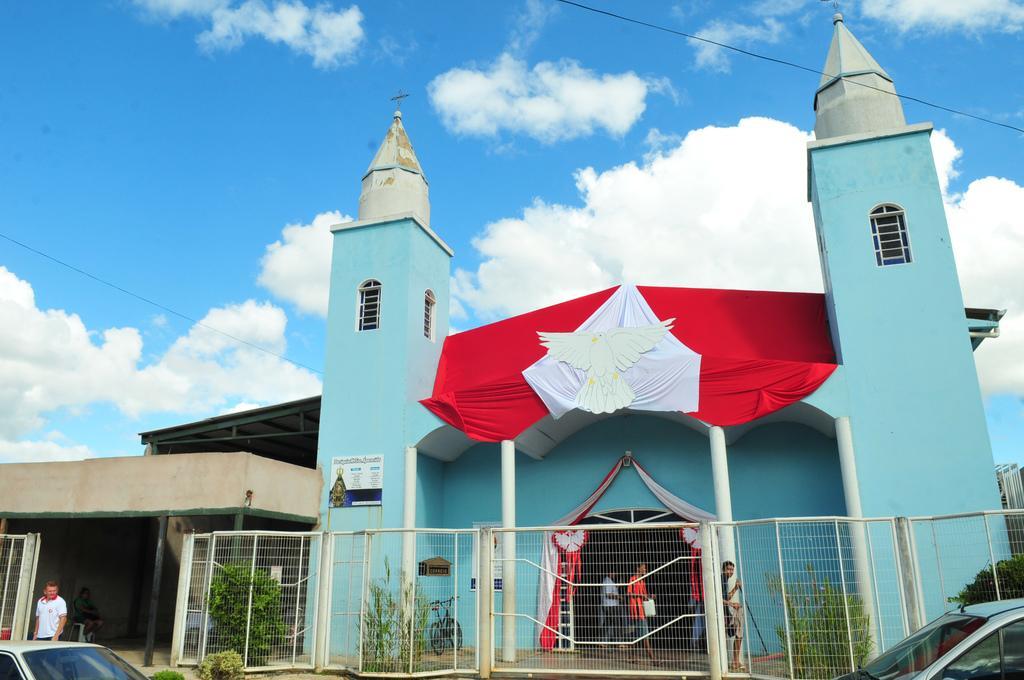How would you summarize this image in a sentence or two? In this image we can see a building, fence, poles, windows, plants, bicycle, vehicles, sheds, and people. In the background there is sky with clouds. 